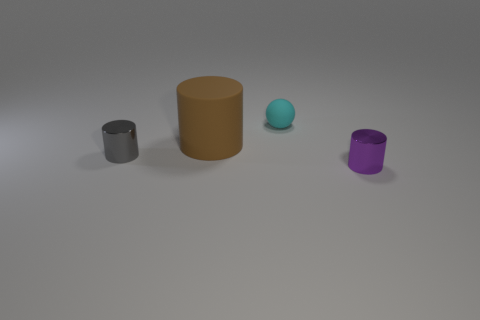There is a tiny thing that is behind the small metallic object behind the small shiny thing that is to the right of the brown cylinder; what shape is it?
Offer a terse response. Sphere. What number of other objects are the same shape as the gray shiny object?
Offer a terse response. 2. How many cylinders are there?
Your answer should be very brief. 3. What number of objects are small yellow shiny cylinders or small things?
Give a very brief answer. 3. Are there any gray cylinders behind the brown matte thing?
Ensure brevity in your answer.  No. Is the number of tiny things behind the large brown matte cylinder greater than the number of large brown rubber objects that are behind the small matte sphere?
Provide a succinct answer. Yes. There is another shiny object that is the same shape as the purple thing; what is its size?
Your response must be concise. Small. How many cylinders are either small shiny objects or big things?
Provide a short and direct response. 3. Is the number of small cylinders on the right side of the cyan matte thing less than the number of small objects on the left side of the small purple cylinder?
Give a very brief answer. Yes. What number of things are small shiny objects that are in front of the small gray cylinder or cyan balls?
Give a very brief answer. 2. 